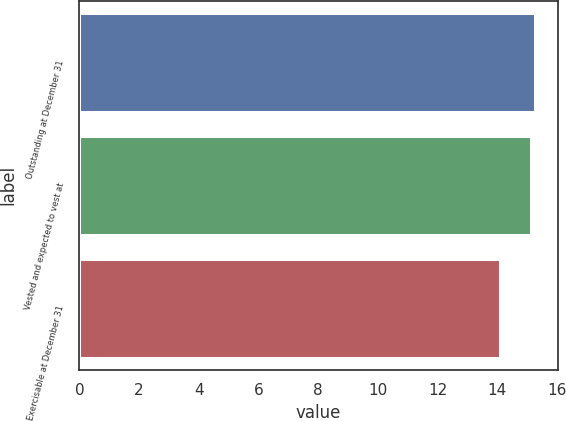<chart> <loc_0><loc_0><loc_500><loc_500><bar_chart><fcel>Outstanding at December 31<fcel>Vested and expected to vest at<fcel>Exercisable at December 31<nl><fcel>15.27<fcel>15.14<fcel>14.1<nl></chart> 